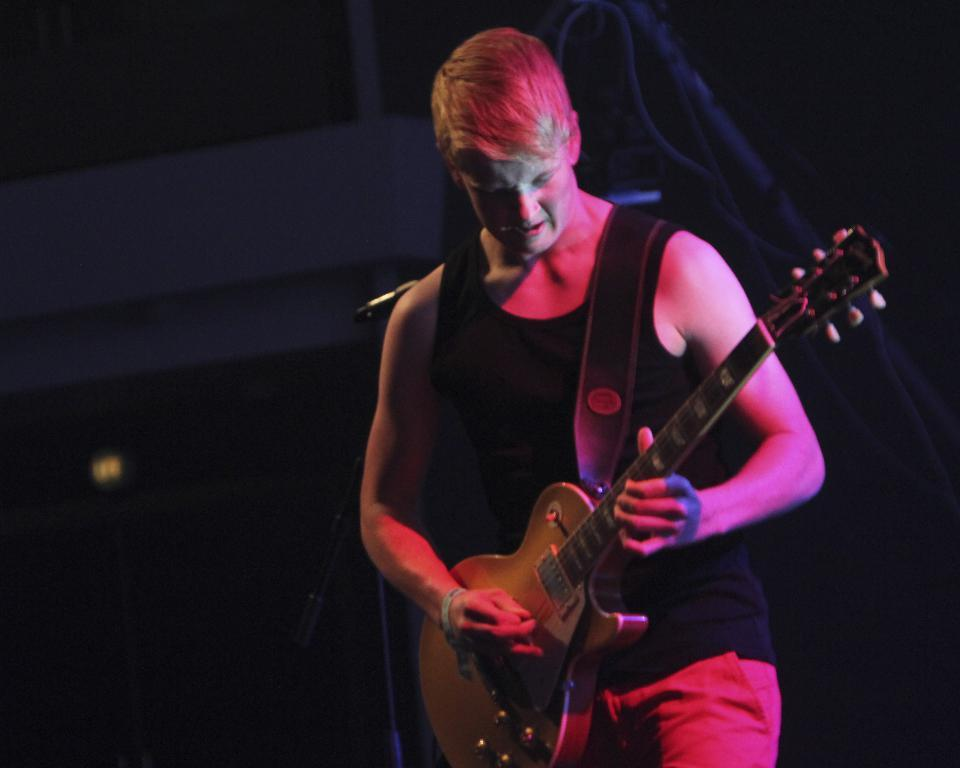What is the main subject of the image? The main subject of the image is a man. What is the man wearing? The man is wearing a black t-shirt. What object is the man holding? The man is holding a guitar. What can be seen to the left side of the man? There is a microphone with a stand to the left side of the man. What is visible behind the man? There is a wall behind the man. What else can be seen in the image? There are cables visible in the image. What direction is the man facing in the image? The direction the man is facing cannot be determined from the image alone. How does the man feel while holding the guitar in the image? The image does not provide any information about the man's feelings or emotions. 